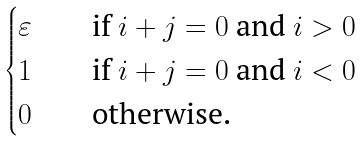Convert formula to latex. <formula><loc_0><loc_0><loc_500><loc_500>\begin{cases} \varepsilon \quad & \text {if } i + j = 0 \text { and } i > 0 \\ 1 & \text {if } i + j = 0 \text { and } i < 0 \\ 0 & \text {otherwise.} \end{cases}</formula> 